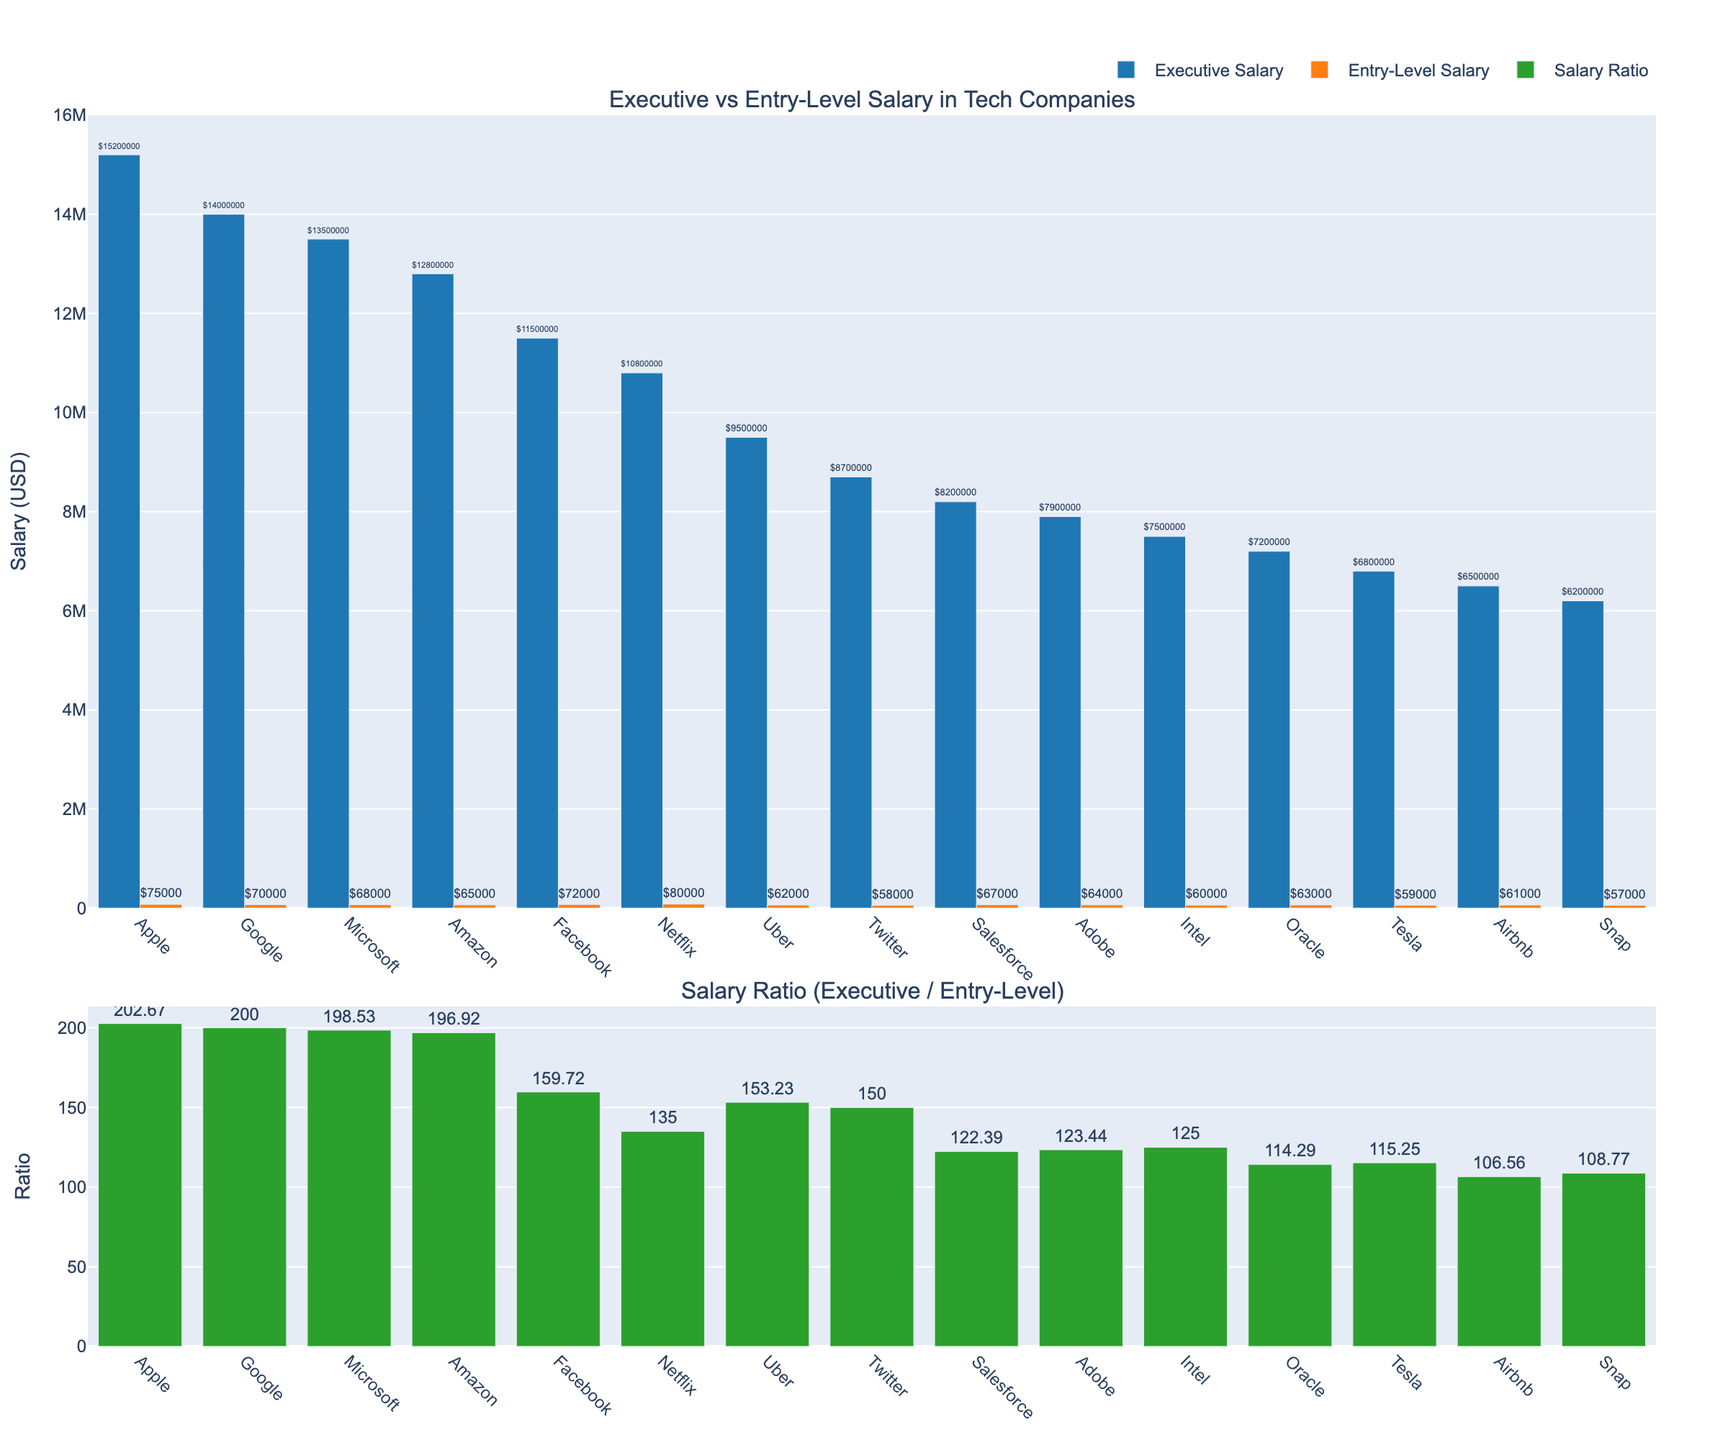Which company has the highest executive salary? The executive salary bars are displayed, and the bar for Apple is the tallest among them.
Answer: Apple Which company has the smallest ratio of executive to entry-level salaries? The second subplot shows the salary ratios, and the bar for Airbnb is the shortest.
Answer: Airbnb How much more does an executive at Google earn compared to an entry-level employee at the same company? The executive salary for Google is $14,000,000, and the entry-level salary is $70,000. Subtract the entry-level salary from the executive salary: $14,000,000 - $70,000 = $13,930,000.
Answer: $13,930,000 Among the companies listed, which one has a higher entry-level salary: Facebook or Netflix? The entry-level salary bars indicate that Netflix has an entry-level salary of $80,000, whereas Facebook's entry-level salary is $72,000.
Answer: Netflix Which company has a lower executive salary: Salesforce or Tesla? Comparing the executive salary bars for both companies, Salesforce has an executive salary of $8,200,000, while Tesla has an executive salary of $6,800,000.
Answer: Tesla What is the sum of the entry-level salaries for Amazon and Uber? Amazon's entry-level salary is $65,000, and Uber's entry-level salary is $62,000. Adding them together: $65,000 + $62,000 = $127,000.
Answer: $127,000 What is the ratio of executive to entry-level salaries at Oracle? The ratio bar for Oracle shows a value of 114.29. This value is also directly stated in the data.
Answer: 114.29 How much more does an executive at Amazon earn than a similar position at Oracle? Amazon's executive salary is $12,800,000, and Oracle's executive salary is $7,200,000. Subtract Oracle's executive salary from Amazon's: $12,800,000 - $7,200,000 = $5,600,000.
Answer: $5,600,000 Which company has the smallest difference between executive and entry-level salaries? Subtract the entry-level salaries from the executive salaries and compare. The smallest difference is for Airbnb: $6,500,000 - $61,000 = $6,439,000.
Answer: Airbnb What is the average ratio of executive to entry-level salaries across all companies? Sum all the ratios: 202.67 + 200.00 + 198.53 + 196.92 + 159.72 + 135.00 + 153.23 + 150.00 + 122.39 + 123.44 + 125.00 + 114.29 + 115.25 + 106.56 + 108.77 = 2209.77. There are 15 companies, so the average ratio is 2209.77 / 15 = 147.32.
Answer: 147.32 